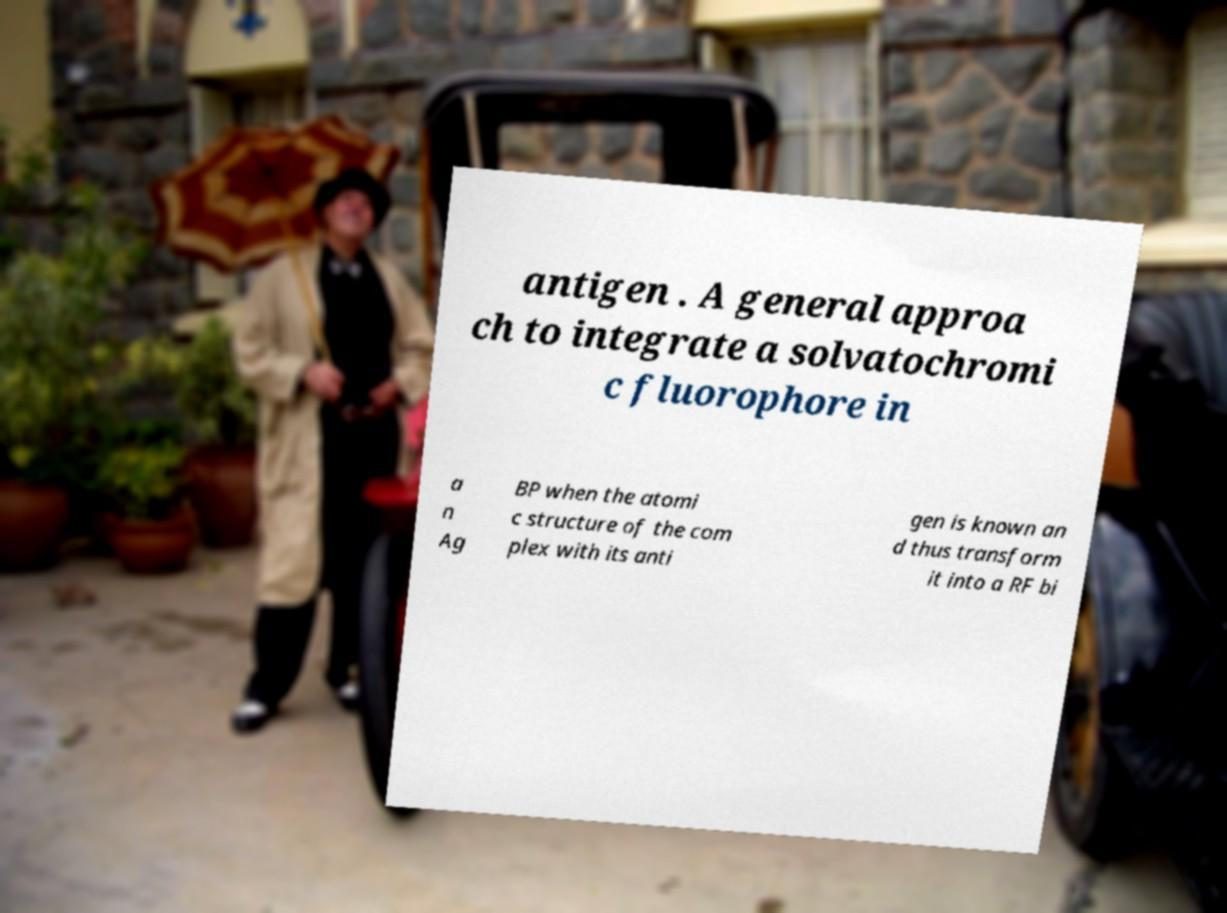Can you accurately transcribe the text from the provided image for me? antigen . A general approa ch to integrate a solvatochromi c fluorophore in a n Ag BP when the atomi c structure of the com plex with its anti gen is known an d thus transform it into a RF bi 